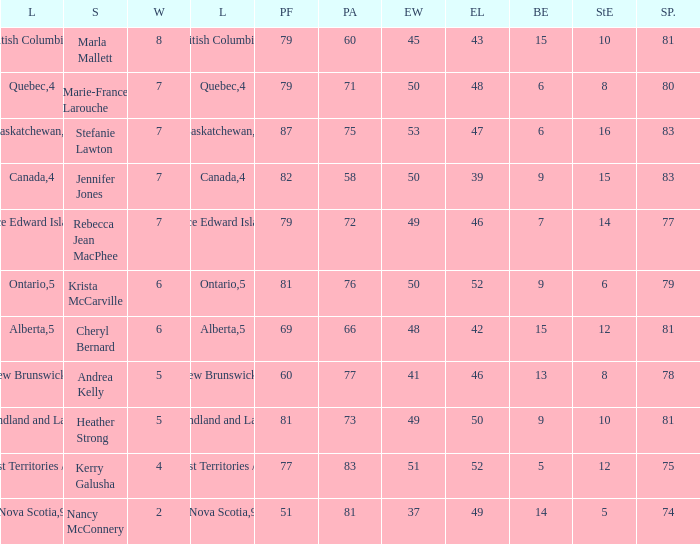Would you be able to parse every entry in this table? {'header': ['L', 'S', 'W', 'L', 'PF', 'PA', 'EW', 'EL', 'BE', 'StE', 'SP.'], 'rows': [['British Columbia', 'Marla Mallett', '8', '3', '79', '60', '45', '43', '15', '10', '81'], ['Quebec', 'Marie-France Larouche', '7', '4', '79', '71', '50', '48', '6', '8', '80'], ['Saskatchewan', 'Stefanie Lawton', '7', '4', '87', '75', '53', '47', '6', '16', '83'], ['Canada', 'Jennifer Jones', '7', '4', '82', '58', '50', '39', '9', '15', '83'], ['Prince Edward Island', 'Rebecca Jean MacPhee', '7', '4', '79', '72', '49', '46', '7', '14', '77'], ['Ontario', 'Krista McCarville', '6', '5', '81', '76', '50', '52', '9', '6', '79'], ['Alberta', 'Cheryl Bernard', '6', '5', '69', '66', '48', '42', '15', '12', '81'], ['New Brunswick', 'Andrea Kelly', '5', '6', '60', '77', '41', '46', '13', '8', '78'], ['Newfoundland and Labrador', 'Heather Strong', '5', '6', '81', '73', '49', '50', '9', '10', '81'], ['Northwest Territories / Yukon', 'Kerry Galusha', '4', '7', '77', '83', '51', '52', '5', '12', '75'], ['Nova Scotia', 'Nancy McConnery', '2', '9', '51', '81', '37', '49', '14', '5', '74']]} Where was the shot pct 78? New Brunswick. 